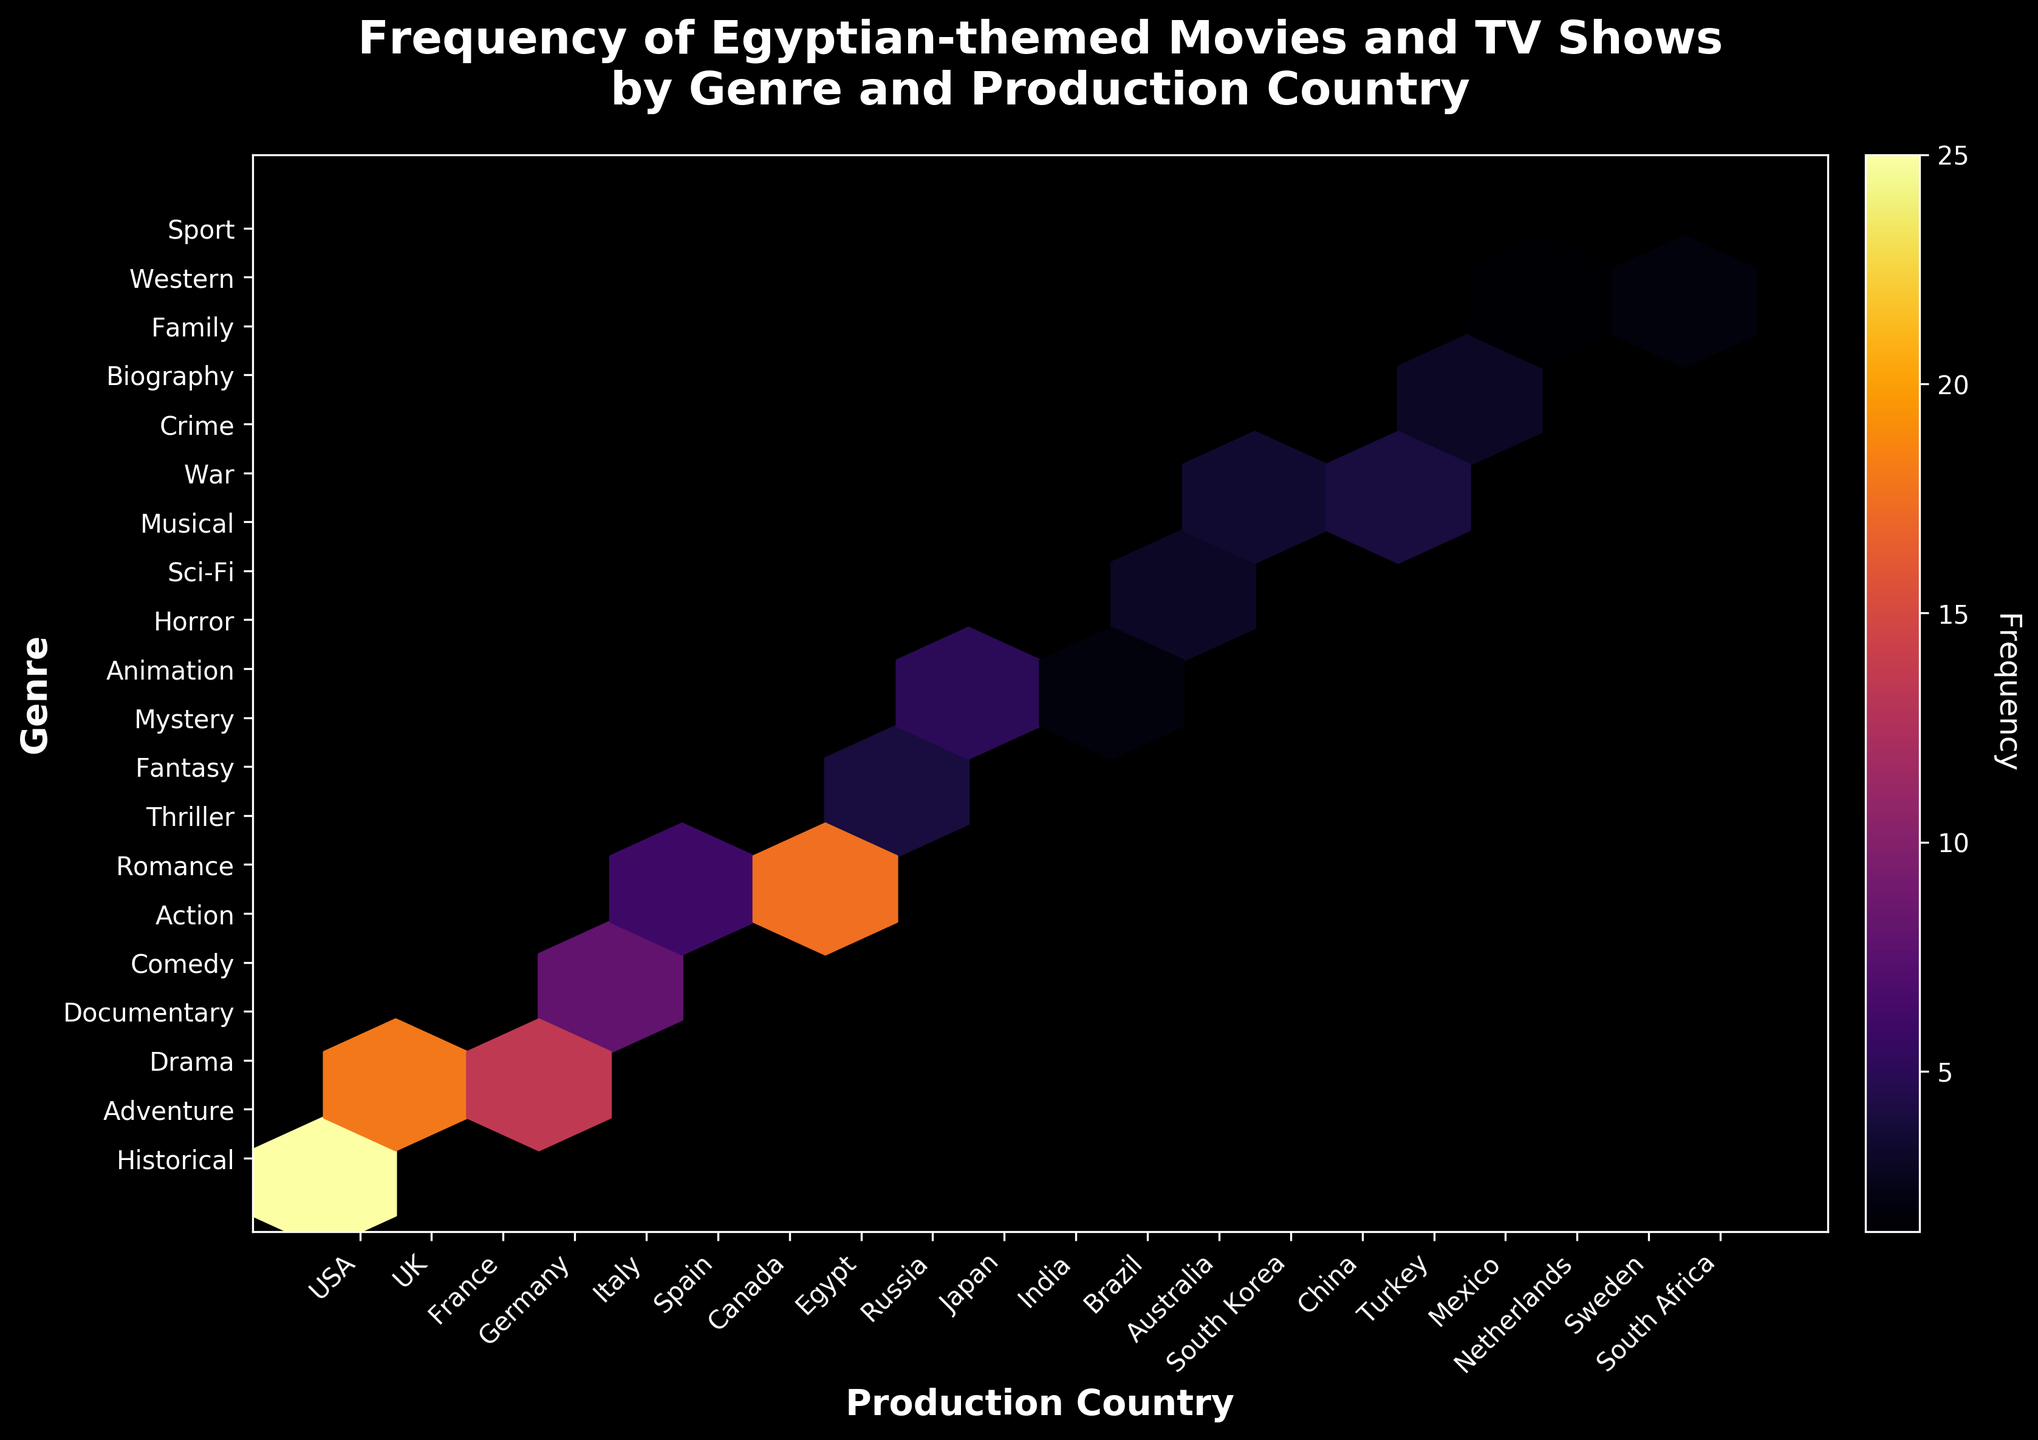What is the title of the plot? The title of the plot is usually the largest text and positioned at the top. Upon examining the figure, the title can be inferred from the combination of prominent labeling.
Answer: Frequency of Egyptian-themed Movies and TV Shows by Genre and Production Country Which production country has the highest frequency of Egyptian-themed movies and TV shows? By looking at the hexagons with higher color intensity in the 'Production Country' axis, and identifying the country based on frequency, Egypt is located at the highest point.
Answer: Egypt Which genre has the most Egyptian-themed movies and TV shows produced? The genre associated with the highest frequency hexagon (darker color) in the 'Genre' axis indicates the genre. Thriller is the most frequent genre.
Answer: Thriller What color scheme is used in the hexbin plot? The color scheme can be identified by the gradient from lighter to darker shades, and the name is typically derived from the plot description. The color map 'inferno' is indicated here.
Answer: Inferno How does the frequency of Egyptian-themed movies compare between the USA and UK? By locating the hexagons corresponding to the USA and UK on the 'Production Country' axis and comparing their color intensity, it is evident which has a higher count.
Answer: USA has a higher frequency than the UK Which genres have fewer than 5 Egyptian-themed productions? Identifying the lighter colored hexagons (< 5 frequency) on the 'Genre' axis and checking their corresponding genres shows those with fewer than 5. Fantasy, Mystery, Horror, Sci-Fi, Musical, Western, Family.
Answer: Fantasy, Mystery, Horror, Sci-Fi, Musical, Western, Family Are the productions in the genres 'Comedy' and 'Action' emerging from the same country? By checking the hexagons where 'Comedy' and 'Action' genres align and identifying their 'Production Country' values, we see the corresponding countries differ. Comedy from Italy, Action from Spain.
Answer: No Which country has produced more historical Egyptian-themed movies, the USA or UK? Identify and compare the frequency of Historical genre hexagons (darker color) for USA and UK to determine which is higher. USA appears visually denser than UK.
Answer: USA What is the frequency difference of Egyptian-themed Drama movies between France and Germany? Locate the 'Drama' genre on the plot, identify the hexagons for both France and Germany, and calculate the difference in frequency counts (France 12, Germany 15).
Answer: 3 Has any production country produced 2 genres with the same frequency? Scanning each production country for hexagons with identical shades, confirming if any two genres match in frequency. South Korea produced Musical and Sport both with frequency 2.
Answer: Yes, South Korea 